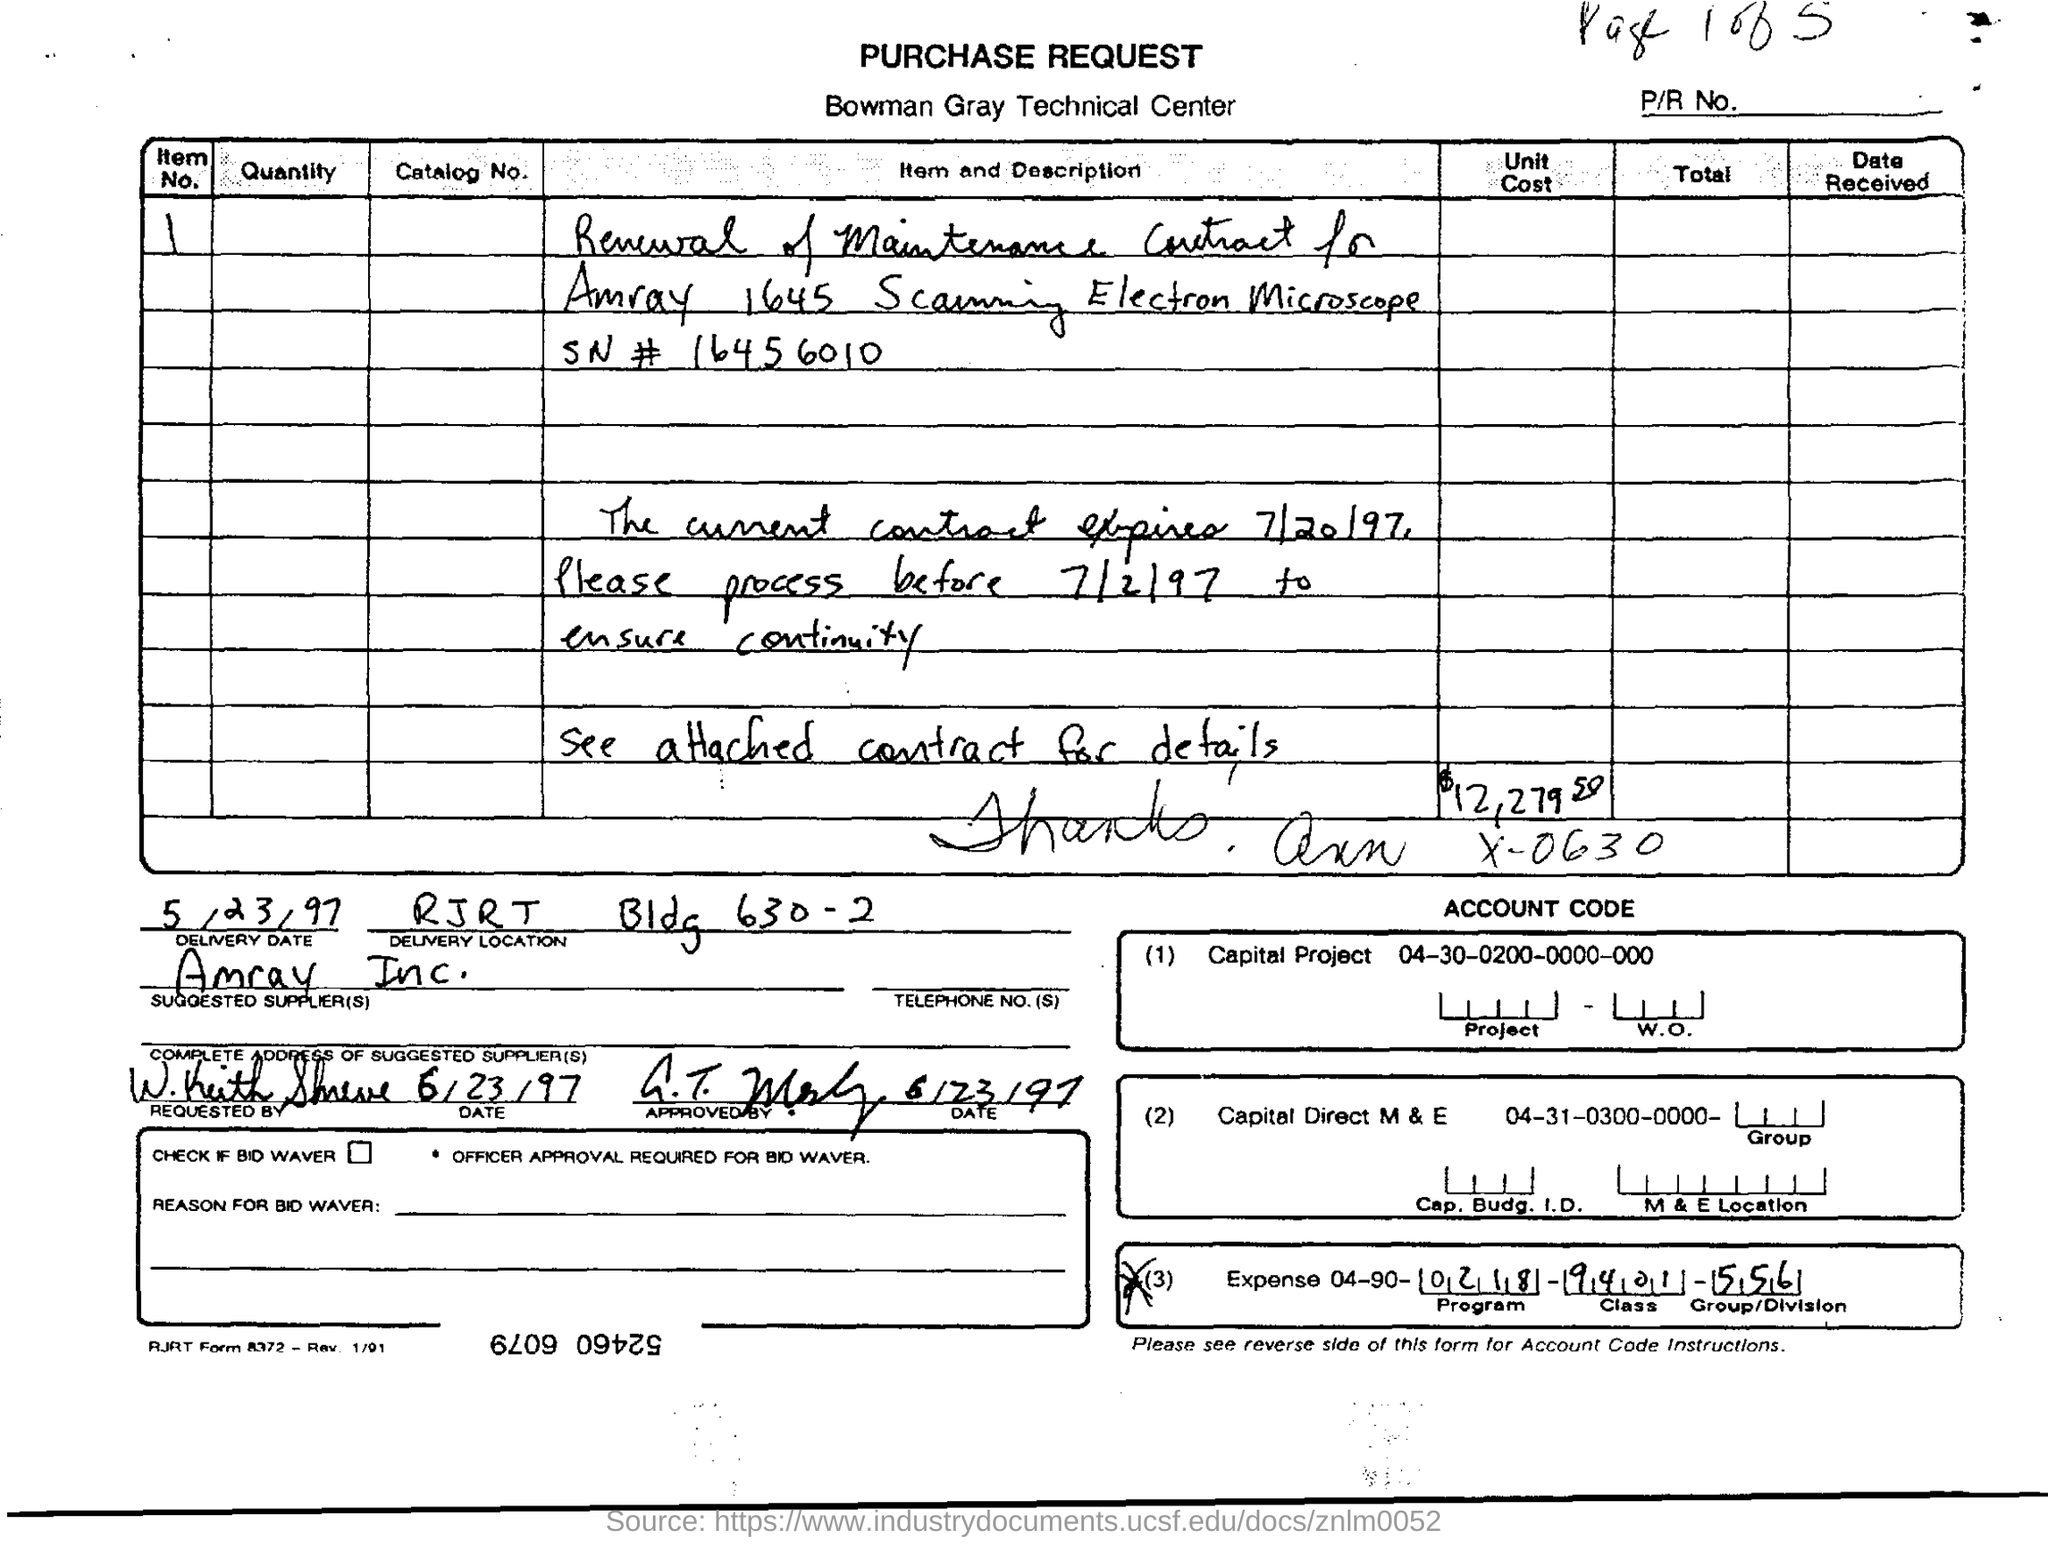What is the delivery date ?
Offer a terse response. 5/23/97. What is the name of the technical center ?
Provide a short and direct response. Bowman Gray. 